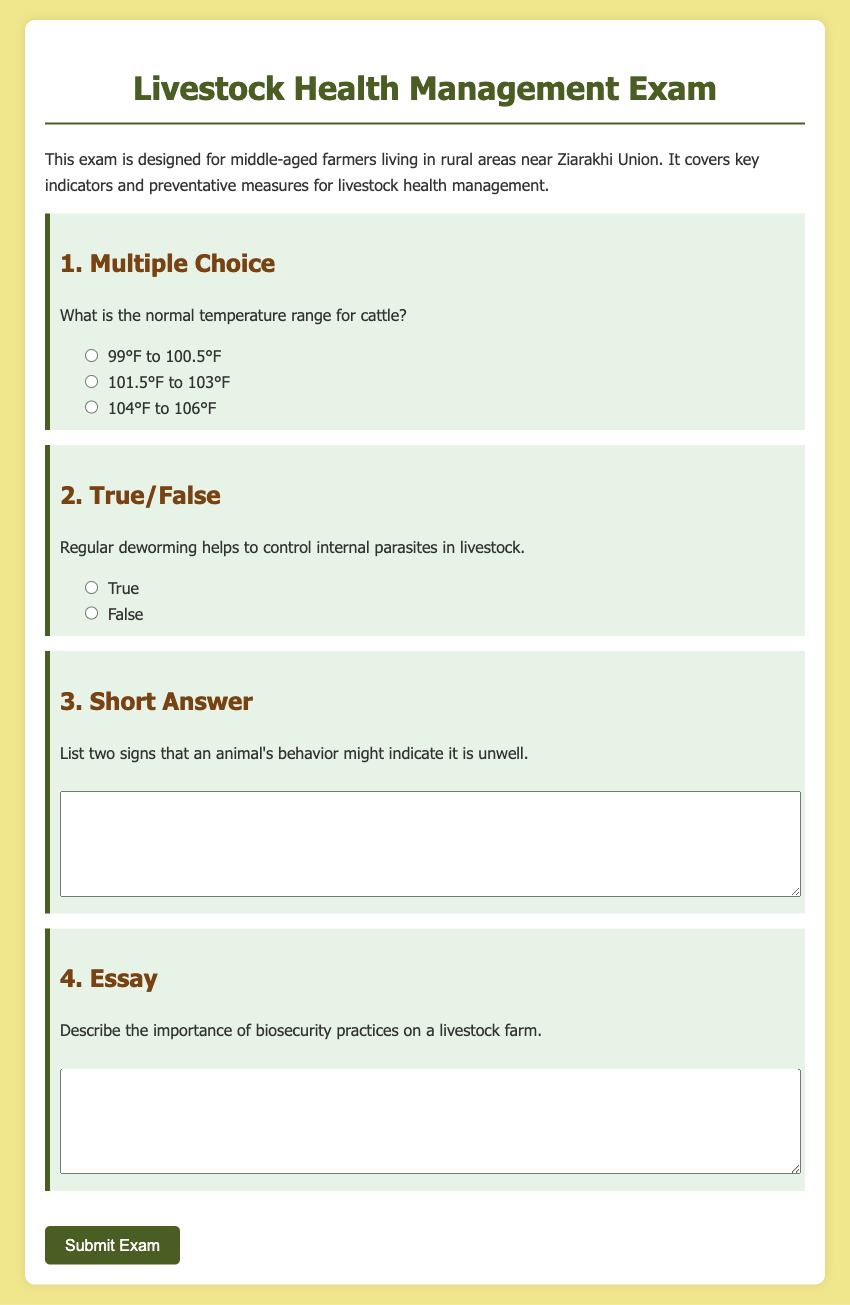What is the title of the document? The title is mentioned in the head section of the HTML as "Livestock Health Management Exam."
Answer: Livestock Health Management Exam What is the normal temperature range for cattle? The normal temperature range for cattle is listed as one of the multiple-choice questions in the document.
Answer: 99°F to 100.5°F How many types of questions are included in the exam? The document specifies four types of questions: multiple choice, true/false, short answer, and essay.
Answer: Four What is the purpose of the exam? The purpose is defined in the introductory paragraph of the document.
Answer: To cover key indicators and preventative measures for livestock health management What is one sign of an animal being unwell? The document asks for signs in the short answer section, implying that there are specific behaviors to indicate this.
Answer: Various; could be lethargy, loss of appetite, etc What practice helps control internal parasites in livestock? The true/false question highlights regular deworming as a measure for controlling parasites.
Answer: Regular deworming What color is the background of the document? The background color is defined in the CSS styling within the document.
Answer: Light yellow (or #f0e68c) What should you click after completing the exam? The document contains a button that prompts action after finishing the exam.
Answer: Submit Exam 